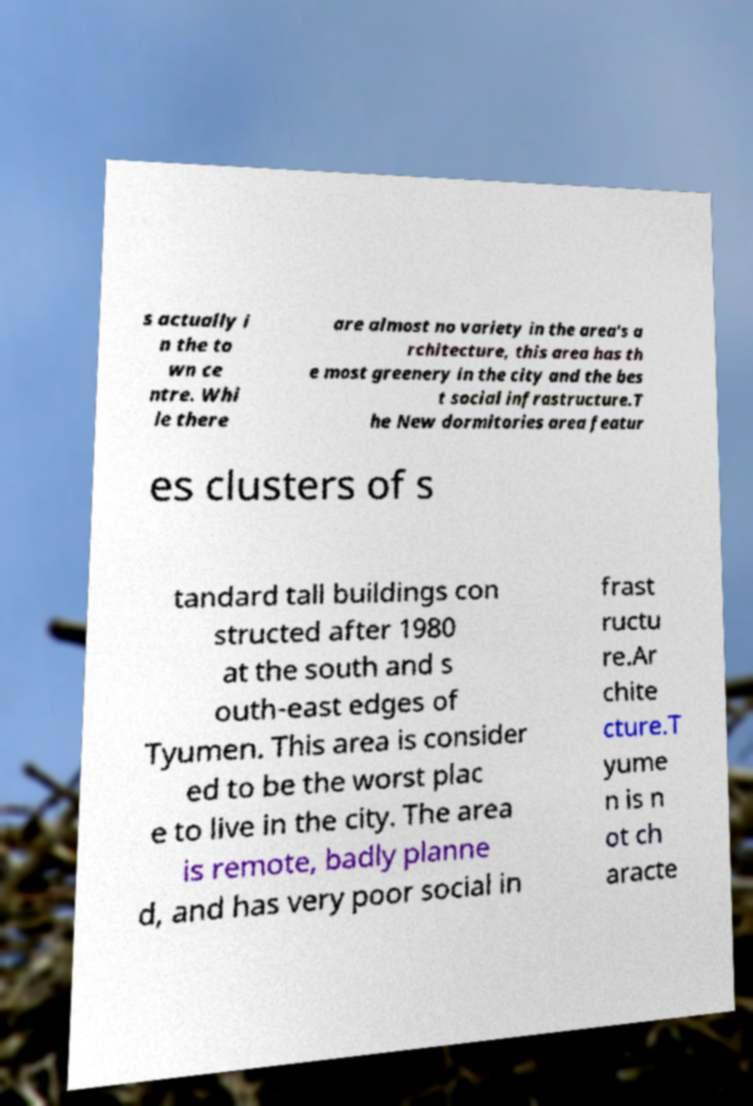I need the written content from this picture converted into text. Can you do that? s actually i n the to wn ce ntre. Whi le there are almost no variety in the area's a rchitecture, this area has th e most greenery in the city and the bes t social infrastructure.T he New dormitories area featur es clusters of s tandard tall buildings con structed after 1980 at the south and s outh-east edges of Tyumen. This area is consider ed to be the worst plac e to live in the city. The area is remote, badly planne d, and has very poor social in frast ructu re.Ar chite cture.T yume n is n ot ch aracte 